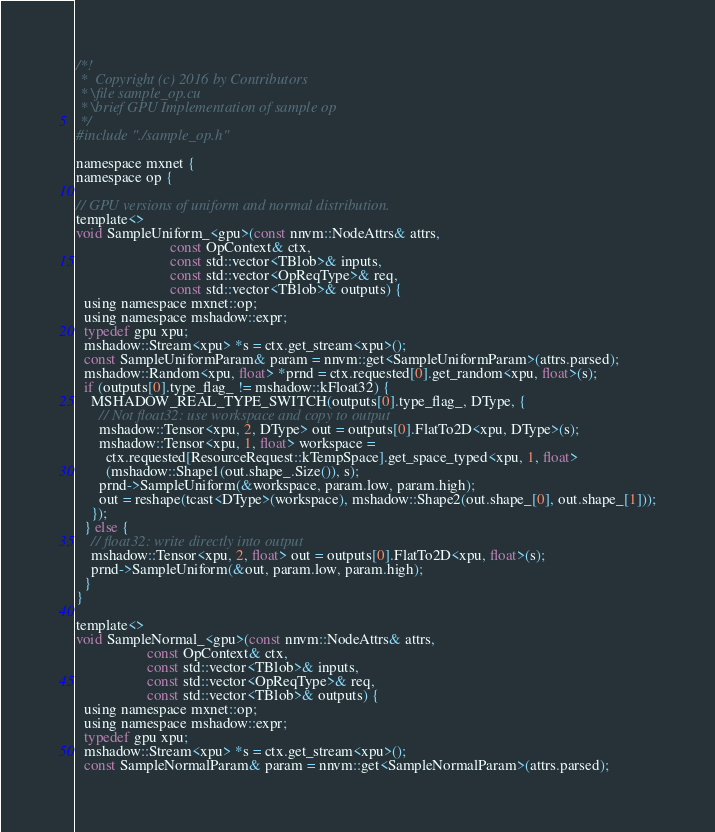<code> <loc_0><loc_0><loc_500><loc_500><_Cuda_>/*!
 *  Copyright (c) 2016 by Contributors
 * \file sample_op.cu
 * \brief GPU Implementation of sample op
 */
#include "./sample_op.h"

namespace mxnet {
namespace op {

// GPU versions of uniform and normal distribution.
template<>
void SampleUniform_<gpu>(const nnvm::NodeAttrs& attrs,
                         const OpContext& ctx,
                         const std::vector<TBlob>& inputs,
                         const std::vector<OpReqType>& req,
                         const std::vector<TBlob>& outputs) {
  using namespace mxnet::op;
  using namespace mshadow::expr;
  typedef gpu xpu;
  mshadow::Stream<xpu> *s = ctx.get_stream<xpu>();
  const SampleUniformParam& param = nnvm::get<SampleUniformParam>(attrs.parsed);
  mshadow::Random<xpu, float> *prnd = ctx.requested[0].get_random<xpu, float>(s);
  if (outputs[0].type_flag_ != mshadow::kFloat32) {
    MSHADOW_REAL_TYPE_SWITCH(outputs[0].type_flag_, DType, {
      // Not float32: use workspace and copy to output
      mshadow::Tensor<xpu, 2, DType> out = outputs[0].FlatTo2D<xpu, DType>(s);
      mshadow::Tensor<xpu, 1, float> workspace =
        ctx.requested[ResourceRequest::kTempSpace].get_space_typed<xpu, 1, float>
        (mshadow::Shape1(out.shape_.Size()), s);
      prnd->SampleUniform(&workspace, param.low, param.high);
      out = reshape(tcast<DType>(workspace), mshadow::Shape2(out.shape_[0], out.shape_[1]));
    });
  } else {
    // float32: write directly into output
    mshadow::Tensor<xpu, 2, float> out = outputs[0].FlatTo2D<xpu, float>(s);
    prnd->SampleUniform(&out, param.low, param.high);
  }
}

template<>
void SampleNormal_<gpu>(const nnvm::NodeAttrs& attrs,
                   const OpContext& ctx,
                   const std::vector<TBlob>& inputs,
                   const std::vector<OpReqType>& req,
                   const std::vector<TBlob>& outputs) {
  using namespace mxnet::op;
  using namespace mshadow::expr;
  typedef gpu xpu;
  mshadow::Stream<xpu> *s = ctx.get_stream<xpu>();
  const SampleNormalParam& param = nnvm::get<SampleNormalParam>(attrs.parsed);</code> 